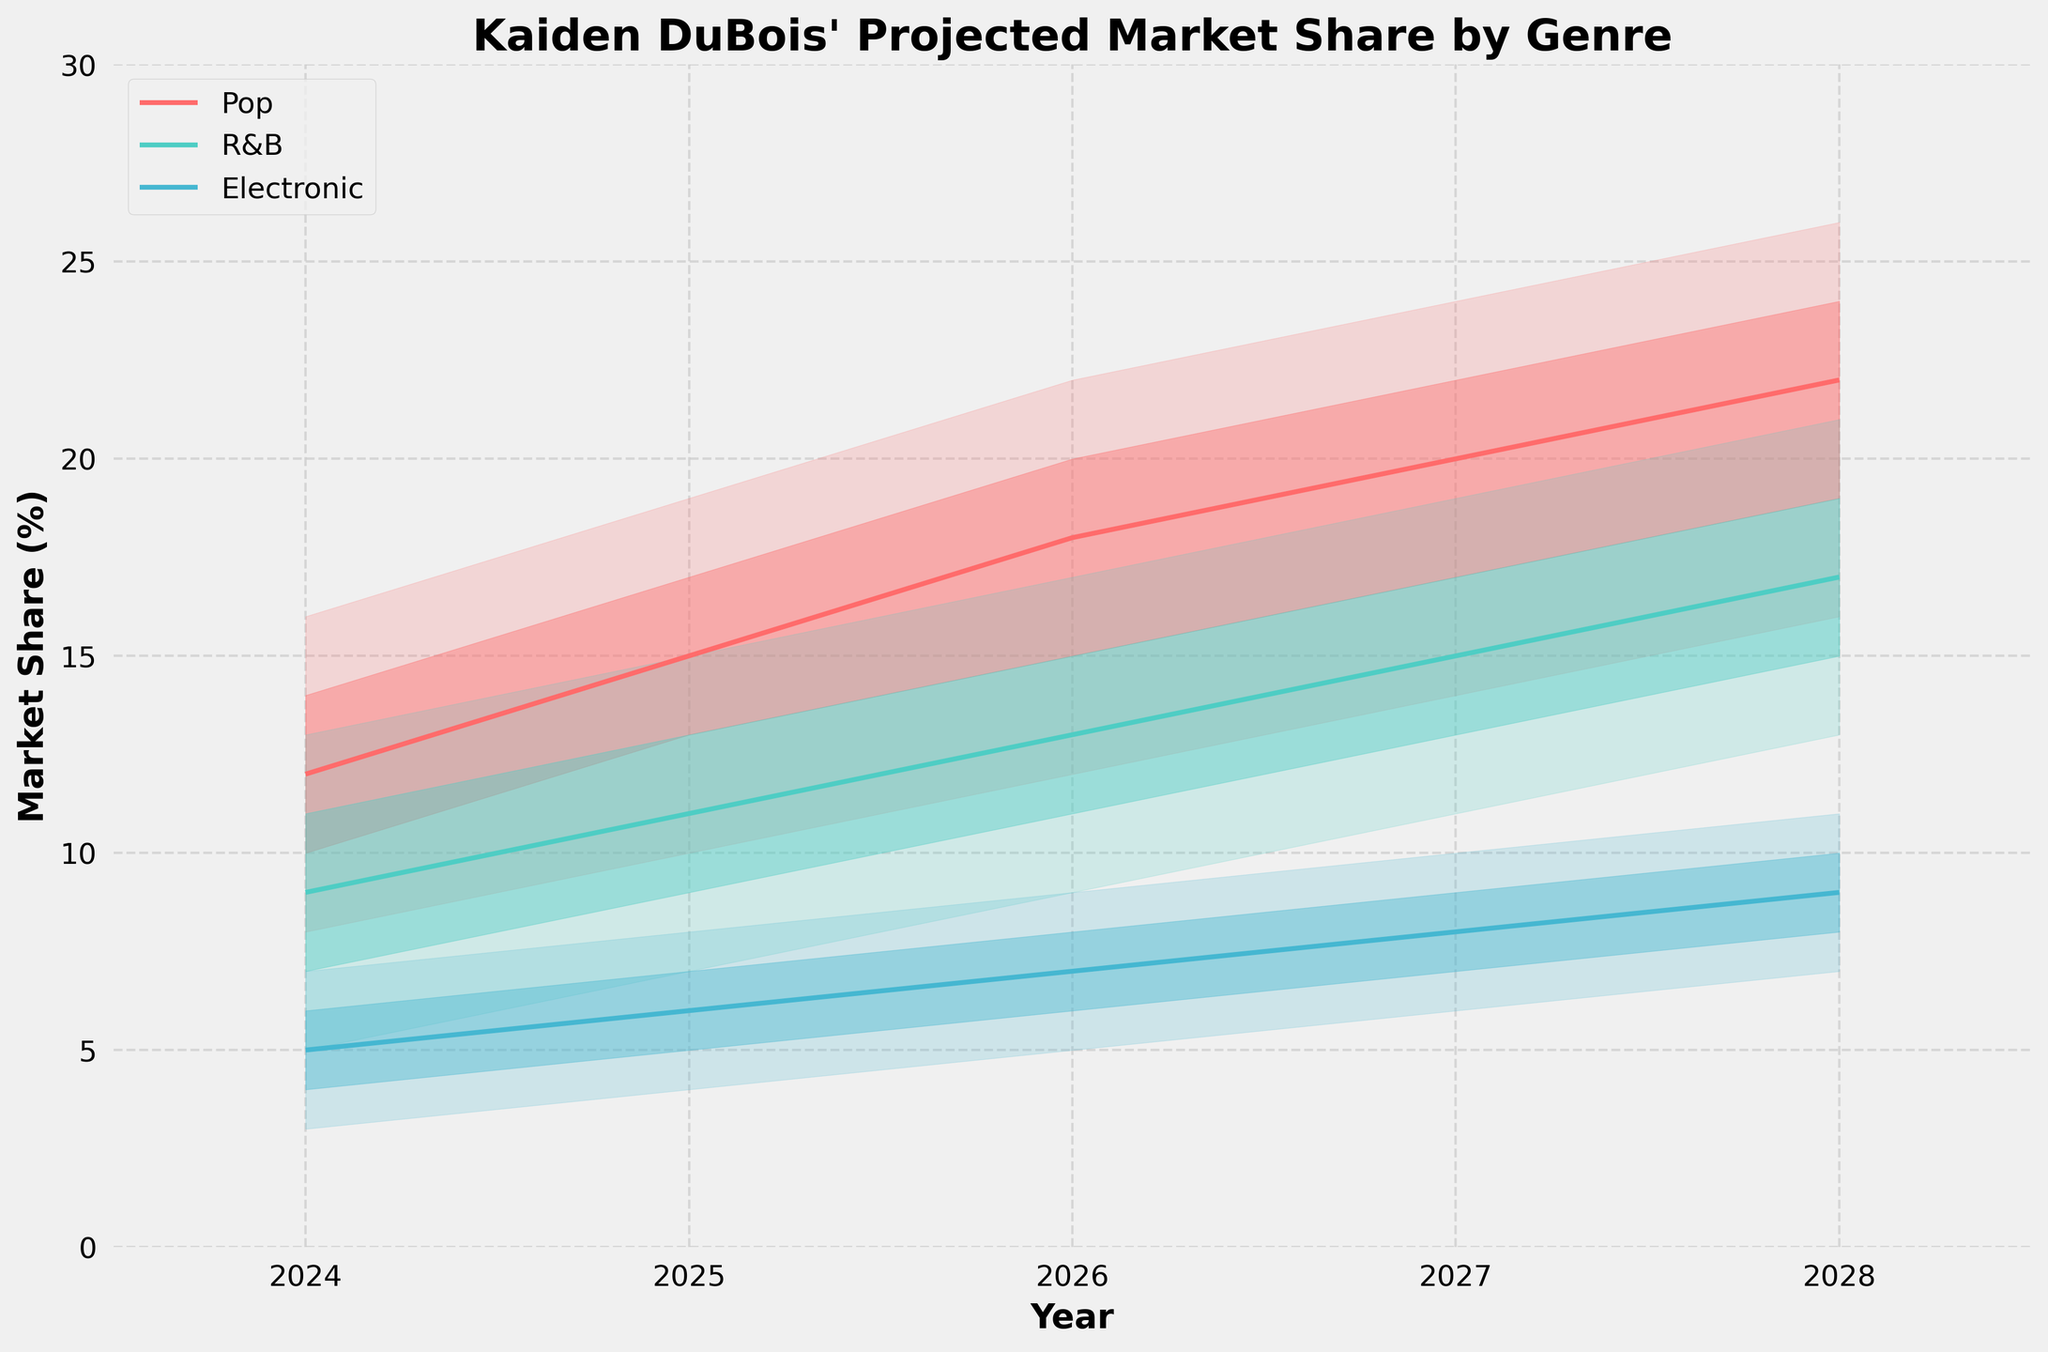What genres are included in the projected market share? The legend in the figure indicates the genres as Pop, R&B, and Electronic.
Answer: Pop, R&B, Electronic What is the projected median market share for Pop in 2026? The figure shows that the median line for Pop in 2026 is marked at the 18% point on the vertical axis.
Answer: 18% Which genre has the highest lower-middle market share estimate in 2025? The lower-middle estimates for 2025 are shown as bands. For Pop, it's 13%; for R&B, it's 9%; for Electronic, it's 5%. Pop has the highest lower-middle estimate.
Answer: Pop How does the projected high estimate for Electronic in 2028 compare to that in 2024? Comparing the high estimate bands for Electronic, it's 7% in 2024 and 11% in 2028, showing an increase of 4 percentage points.
Answer: It increases by 4% Is the market share for R&B expected to be higher or lower than for Electronic in 2027? By looking at the median lines for both genres, R&B has a median around 15% while Electronic has a median around 8% in 2027, making R&B higher.
Answer: Higher What year shows the highest high estimate for Pop? The high estimate for each year is shown on the upper edge of the colored bands for Pop. The highest is at 26% in 2028.
Answer: 2028 How much is the projected median market share for all genres in 2024 combined? Summing up the projected medians for 2024: Pop (12%) + R&B (9%) + Electronic (5%) equals 26%.
Answer: 26% Which year sees the most significant increase in the projected median market share for R&B compared to the previous year? By comparing the medians year by year: 2024 (9%), 2025 (11%) = increase of 2%, 2025 (11%) to 2026 (13%) = increase of 2%, 2026 (13%) to 2027 (15%) = increase of 2%, 2027 (15%) to 2028 (17%) = increase of 2%. All increases are 2%, so any 2-year consecutive time frame applies.
Answer: Each year increase is 2% Which genre has the widest spread between low and high estimates in 2026? The spread is determined by the range between low and high estimates in the respective bands shown on the chart. In 2026, Pop is 22-12=10, R&B is 17-9=8, and Electronic is 9-5=4. Pop has the widest spread.
Answer: Pop What's the trend in the projected median market share for Electronic from 2024 to 2028? Observing the median line for Electronic every year from 2024 (5%) increases steadily to 2028 (9%).
Answer: Increasing 